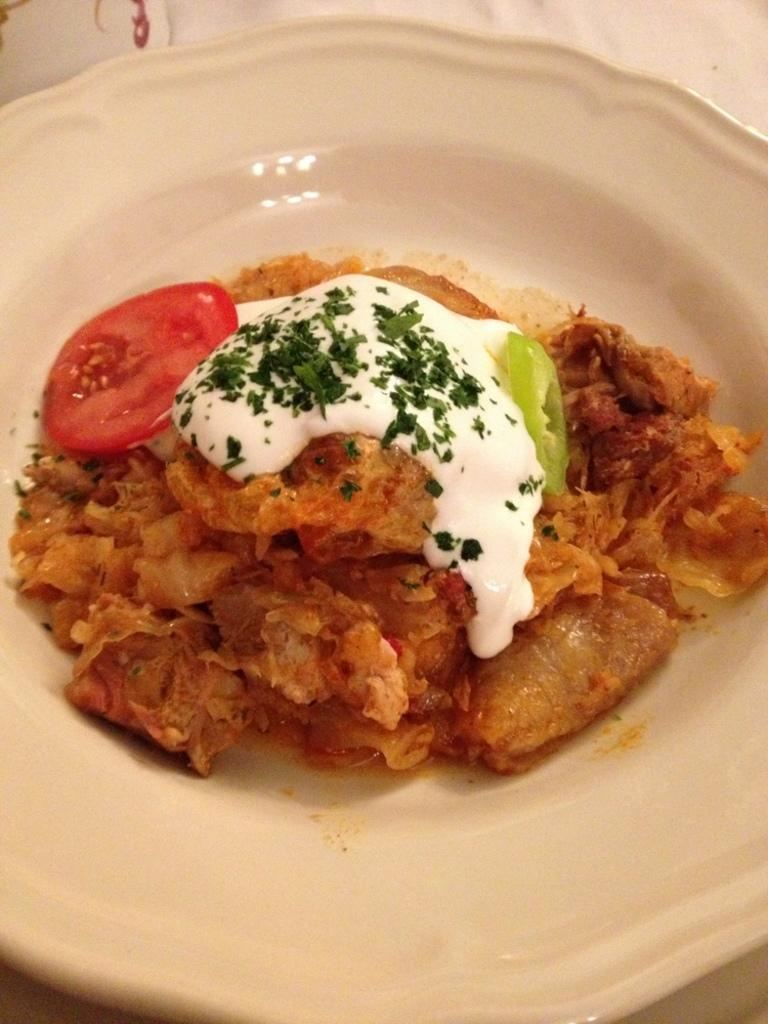What is present on the plate in the image? There is food in a plate in the image. What type of grape can be seen hanging from the plate in the image? There is no grape present on the plate in the image. What type of silk fabric is draped over the plate in the image? There is no silk fabric present in the image; it is a plate of food. 